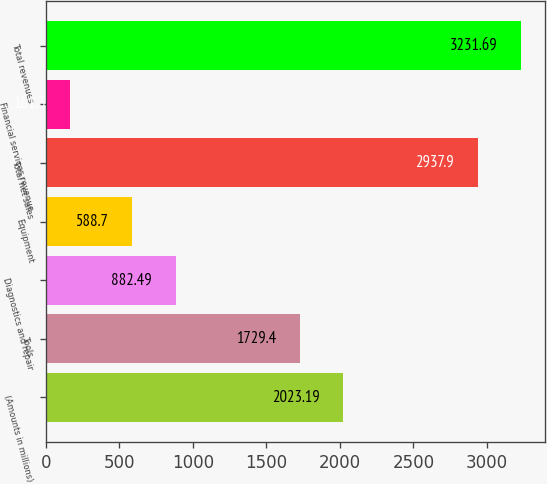Convert chart to OTSL. <chart><loc_0><loc_0><loc_500><loc_500><bar_chart><fcel>(Amounts in millions)<fcel>Tools<fcel>Diagnostics and repair<fcel>Equipment<fcel>Total net sales<fcel>Financial services revenue<fcel>Total revenues<nl><fcel>2023.19<fcel>1729.4<fcel>882.49<fcel>588.7<fcel>2937.9<fcel>161.3<fcel>3231.69<nl></chart> 